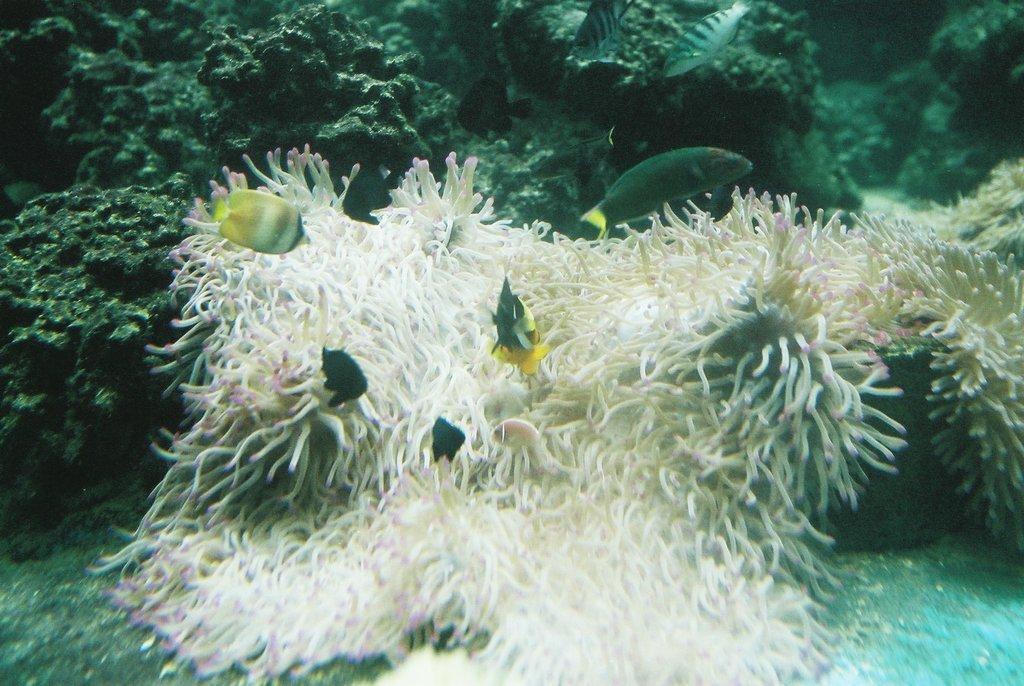Describe this image in one or two sentences. It is the picture of some creature and fishes that are surviving inside the water. 